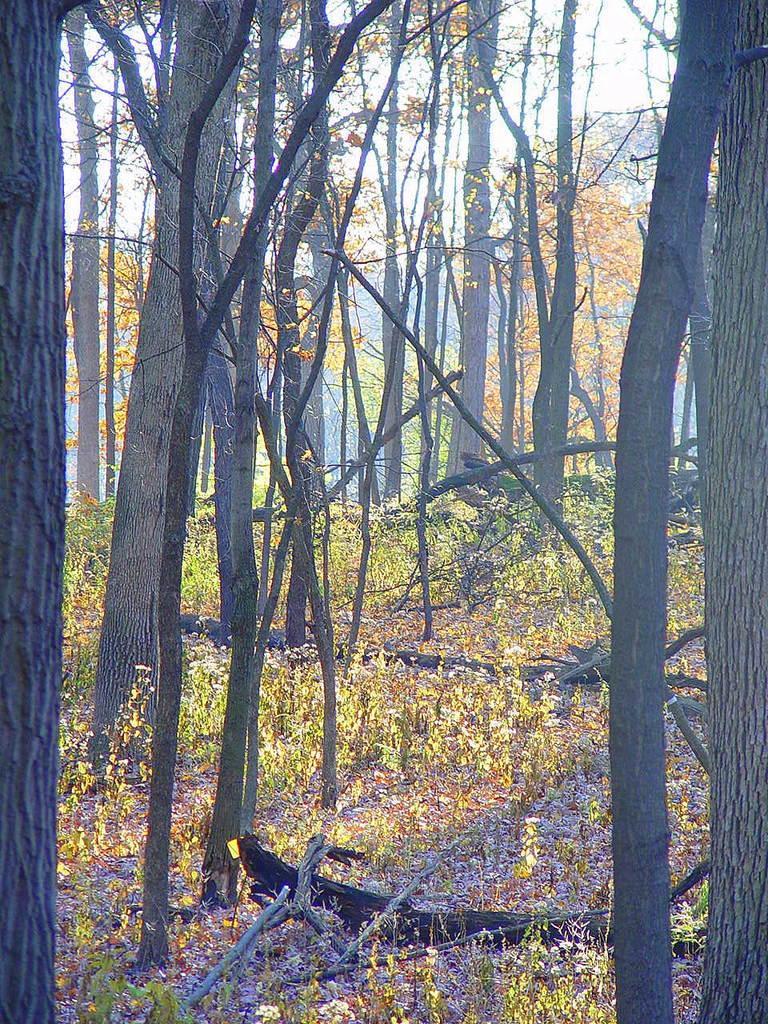How would you summarize this image in a sentence or two? In this picture we can see some trees, at the bottom there is grass, we can see the sky in the background. 